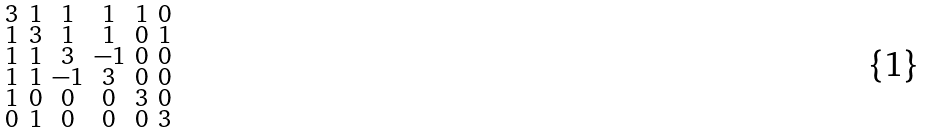Convert formula to latex. <formula><loc_0><loc_0><loc_500><loc_500>\begin{smallmatrix} 3 & 1 & 1 & 1 & 1 & 0 \\ 1 & 3 & 1 & 1 & 0 & 1 \\ 1 & 1 & 3 & - 1 & 0 & 0 \\ 1 & 1 & - 1 & 3 & 0 & 0 \\ 1 & 0 & 0 & 0 & 3 & 0 \\ 0 & 1 & 0 & 0 & 0 & 3 \end{smallmatrix}</formula> 